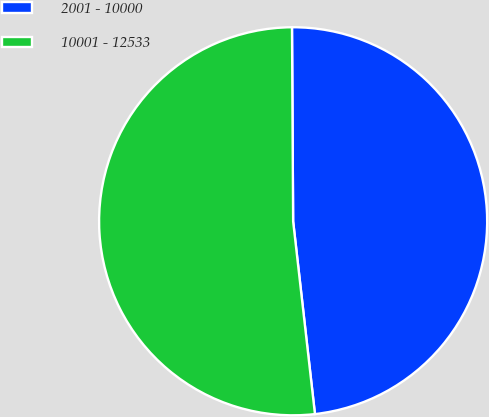Convert chart to OTSL. <chart><loc_0><loc_0><loc_500><loc_500><pie_chart><fcel>2001 - 10000<fcel>10001 - 12533<nl><fcel>48.3%<fcel>51.7%<nl></chart> 